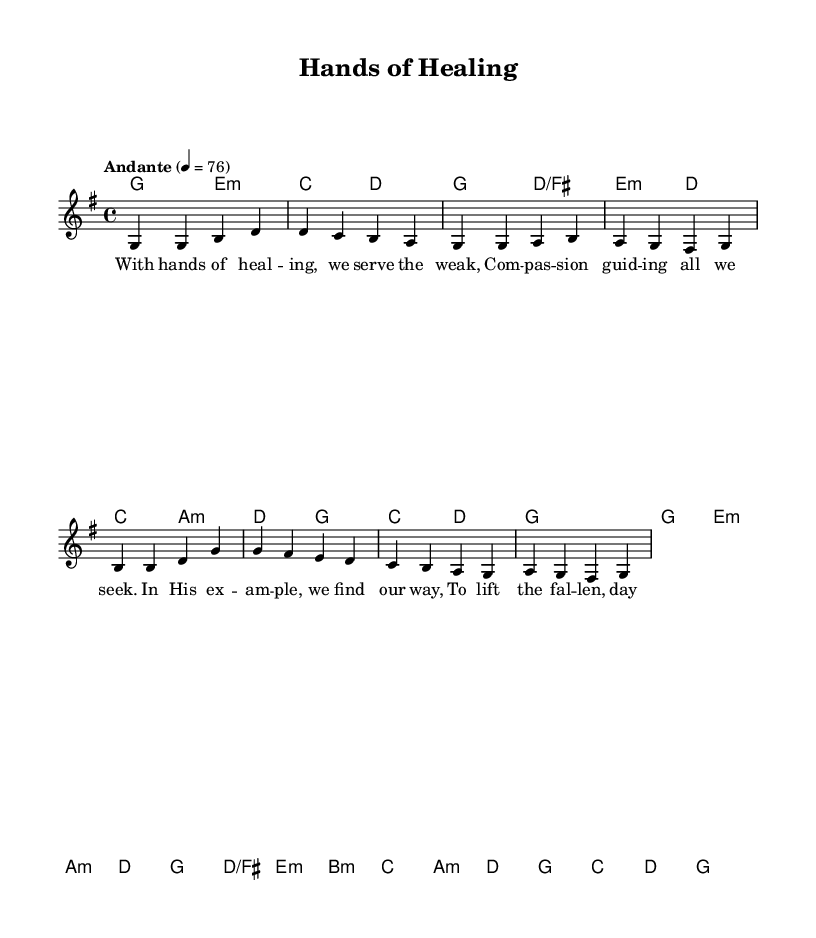What is the key signature of this music? The key signature shows one sharp (F#), which indicates the key of G major.
Answer: G major What is the time signature of this music? The time signature is indicated by the number at the beginning of the staff, which is 4/4, meaning there are four beats in a measure and the quarter note gets one beat.
Answer: 4/4 What is the tempo marking in this sheet music? The tempo marking "Andante" suggests a moderate pace, and the metronome marking of 76 indicates the specific speed at which the piece should be played.
Answer: Andante How many measures are there in the melody section? By counting the groups of bars in the melody section, we find there are a total of 8 measures.
Answer: 8 What is the first lyric line of the hymn? The first line of the lyrics, as presented in the text area under the melody, is "With hands of healing, we serve the weak," indicating the theme of compassion from the start.
Answer: With hands of healing, we serve the weak What do the lyrics indicate about the theme of this hymn? The lyrics reflect themes of service and compassion, emphasizing guidance through example and supporting others, which aligns with traditional religious values of helping the weak and fallen.
Answer: Compassion and service What is the last chord of the piece? The last chord, found at the end of the harmonies section in the score, indicates that the piece resolves on a G major chord, which commonly provides a sense of closure in musical compositions.
Answer: G major 